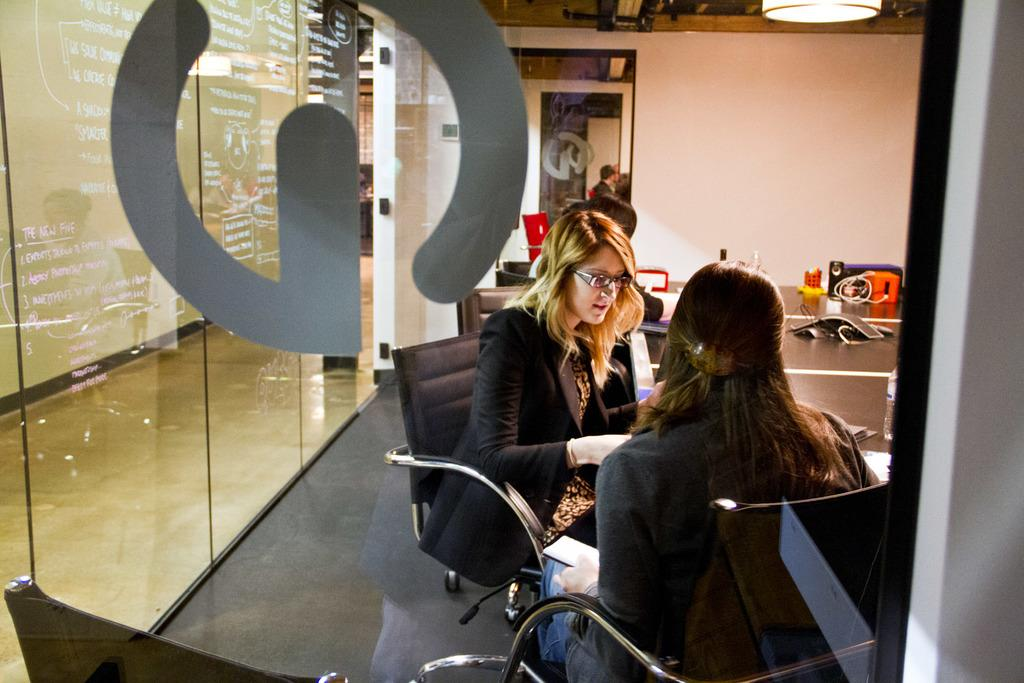How many people are in the image? There are two persons sitting on chairs in the image. What are the people doing in the image? The people are sitting on chairs. Can you describe any objects near the people? There is a glass at the left side of the image. What type of car is visible in the image? There is no car present in the image. What color is the flag being waved by the person in the image? There is no flag or person waving a flag in the image. 